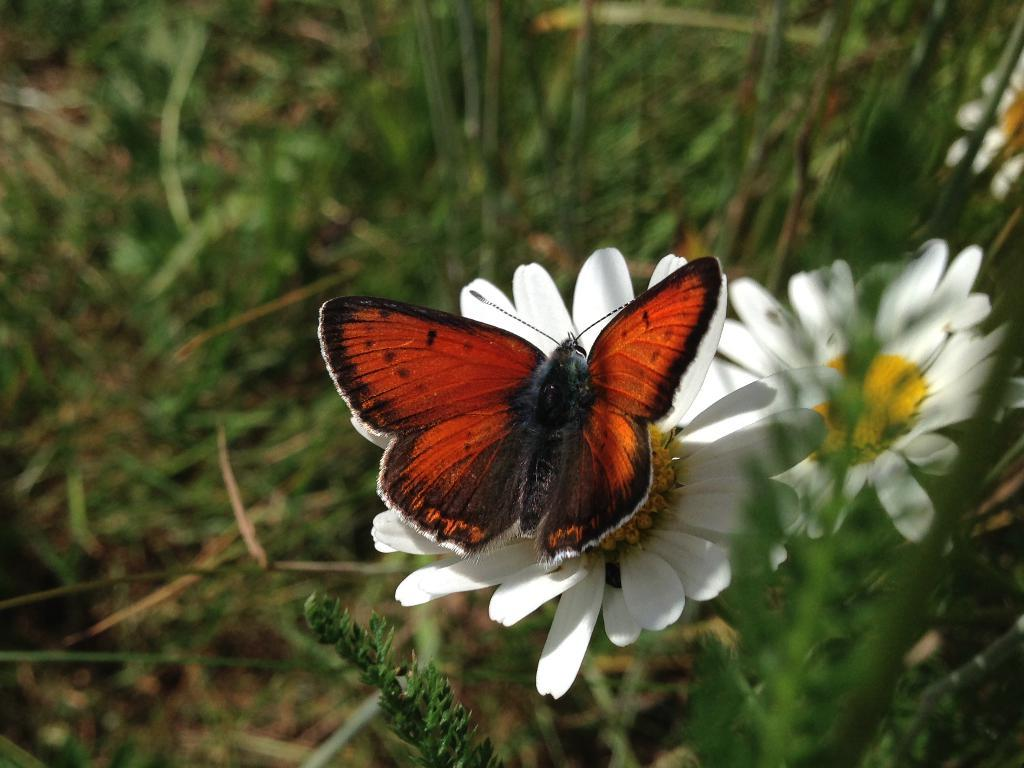What is the main subject of the image? There is a butterfly on a sunflower in the image. What else can be seen in the image besides the butterfly and sunflower? There are plants in the image. What type of vegetation is on the left side of the image? There is grass on the left side of the image. What type of suit is the butterfly wearing in the image? There is no suit present in the image, as butterflies do not wear clothing. 